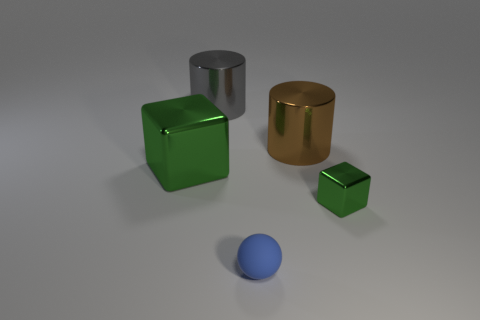Add 3 blue metallic balls. How many objects exist? 8 Subtract all blocks. How many objects are left? 3 Subtract all tiny gray matte cylinders. Subtract all tiny green things. How many objects are left? 4 Add 1 cylinders. How many cylinders are left? 3 Add 2 small yellow balls. How many small yellow balls exist? 2 Subtract 0 yellow blocks. How many objects are left? 5 